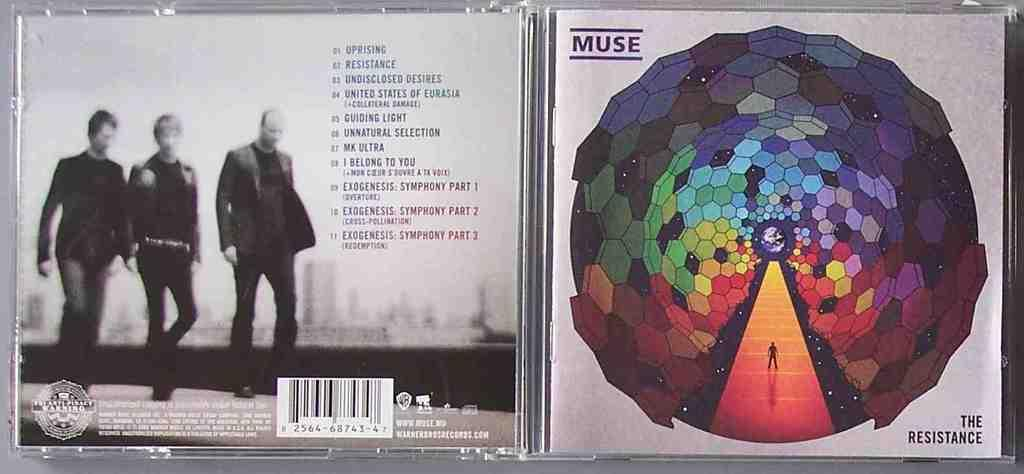What is the main subject of the image? The main subject of the image is a label of a compact disc. Can you describe the label in more detail? Unfortunately, the provided facts do not give any additional details about the label. What type of cloud can be seen in the image? There is no cloud present in the image, as the main subject is a label of a compact disc. How does the jelly contribute to the design of the compact disc label? There is no mention of jelly in the image or the provided facts, so it cannot be determined how it might contribute to the design of the label. 